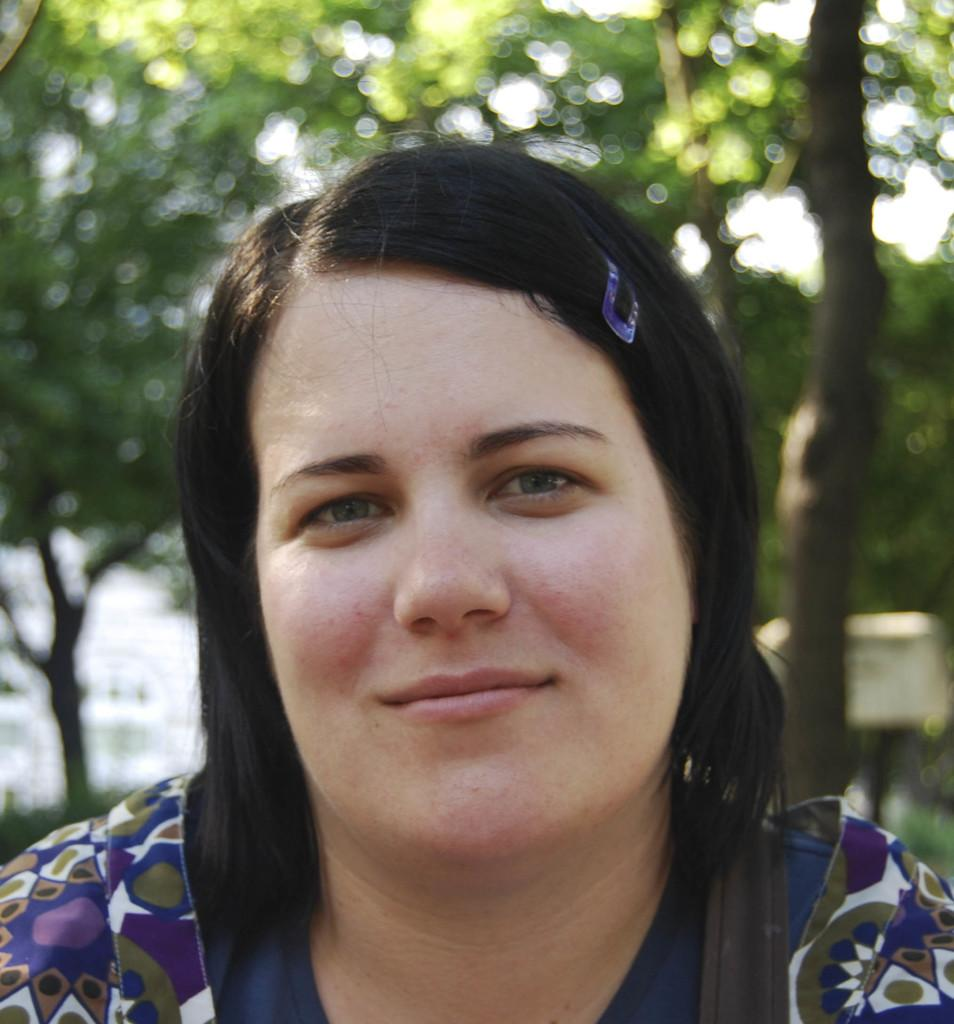Who is present in the image? There is a woman in the image. What is the woman wearing? The woman is wearing a blue dress. What can be seen in the background of the image? There are trees in the background of the image. What type of cable is the woman using to connect to the internet in the image? There is no cable or internet connection present in the image; it features a woman wearing a blue dress with trees in the background. 